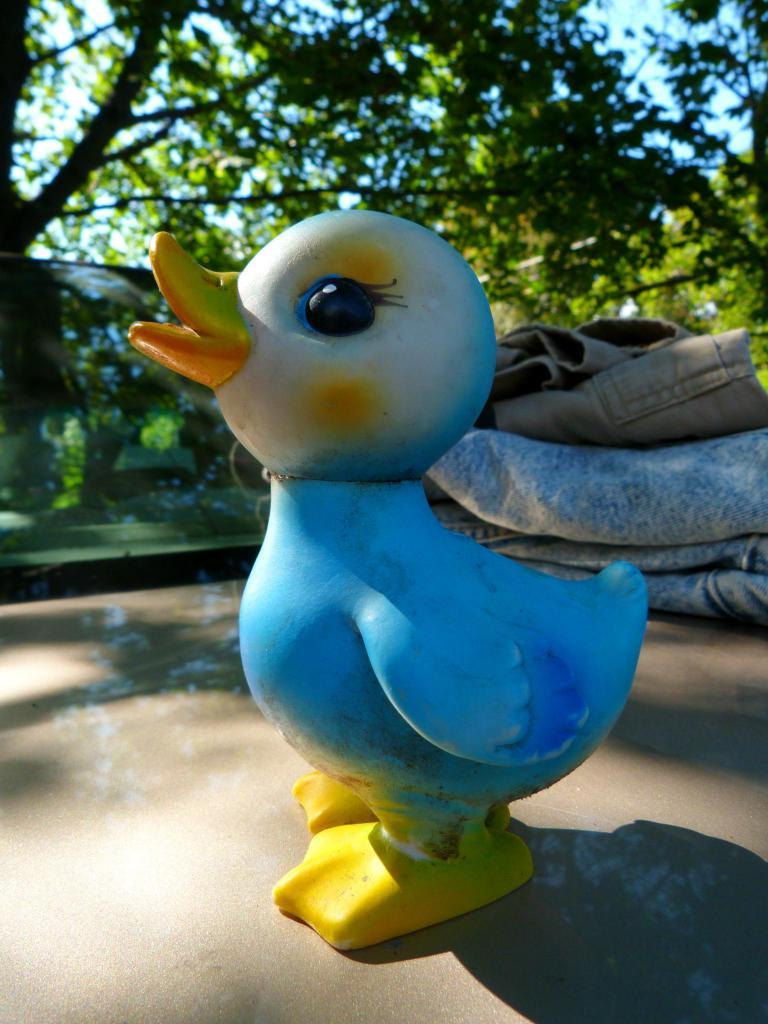What type of toy is present in the image? There is a bird-shaped toy in the image. What else can be seen in the background of the image? There are clothes and trees in the background of the image. What part of the natural environment is visible in the image? The sky is visible in the background of the image. How does the bird-shaped toy walk in the image? The bird-shaped toy does not walk in the image; it is a stationary toy. 